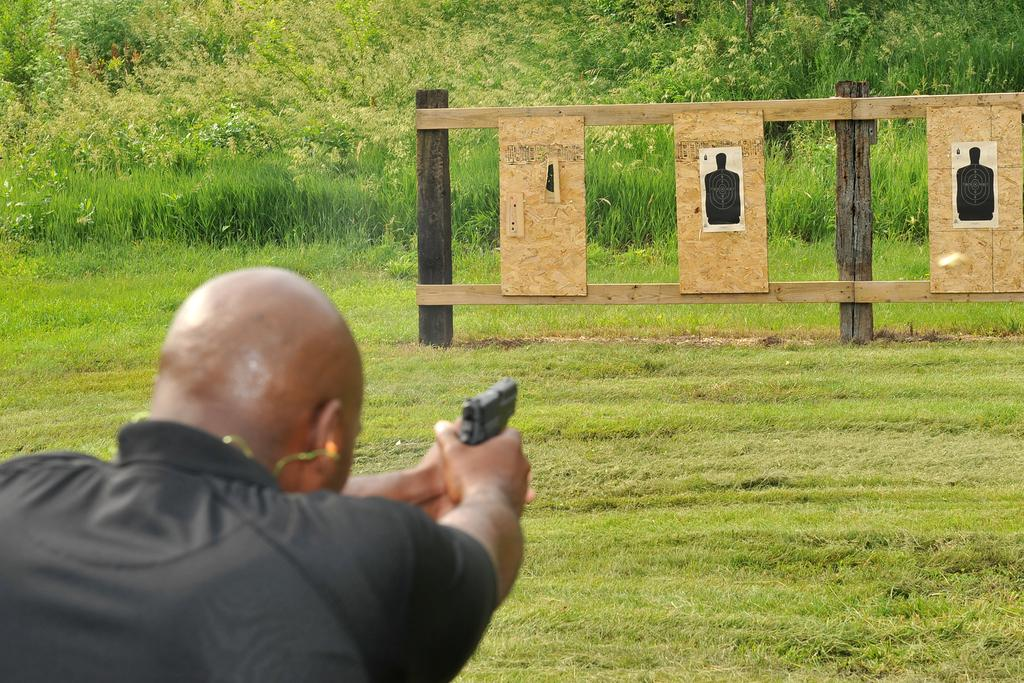What is the appearance of the man in the image? There is a bald-headed man in the image. What is the man wearing in the image? The man is wearing a green shirt. What is the man doing in the image? The man is shooting a gun. What is the target in the image? The target is a wooden board. What is the setting of the scene in the image? The scene is set on a grassland. What type of education does the man have, as indicated by the image? There is no information about the man's education in the image. What degree does the man hold, as suggested by the image? There is no information about the man's degree in the image. 